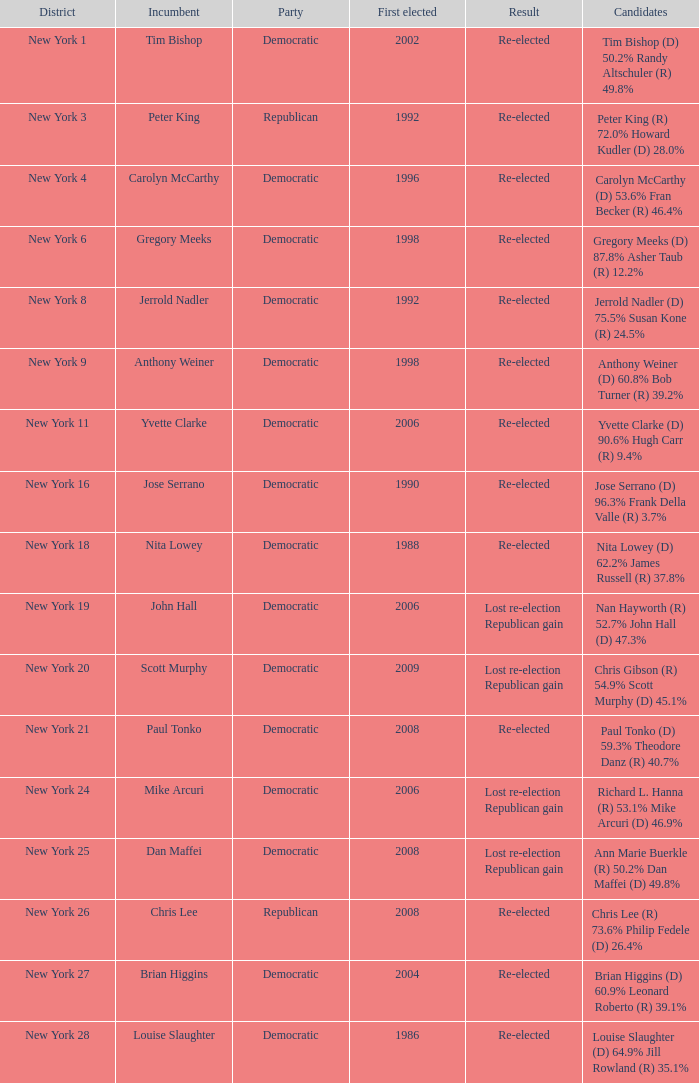Identify the celebration for new york 4 Democratic. 